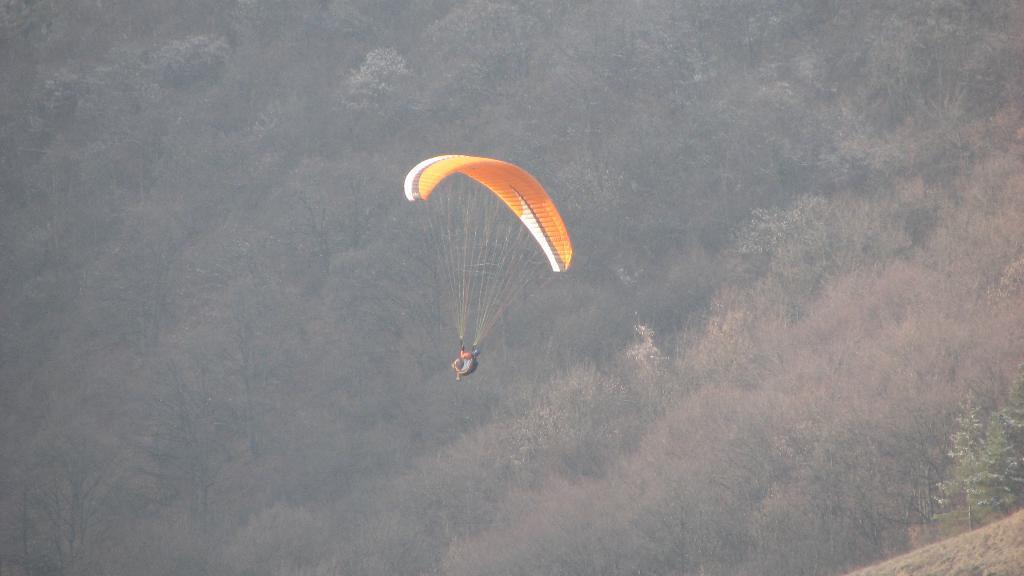In one or two sentences, can you explain what this image depicts? In this image we can see a person with a parachute in the air. There are many trees and plants in the image. 